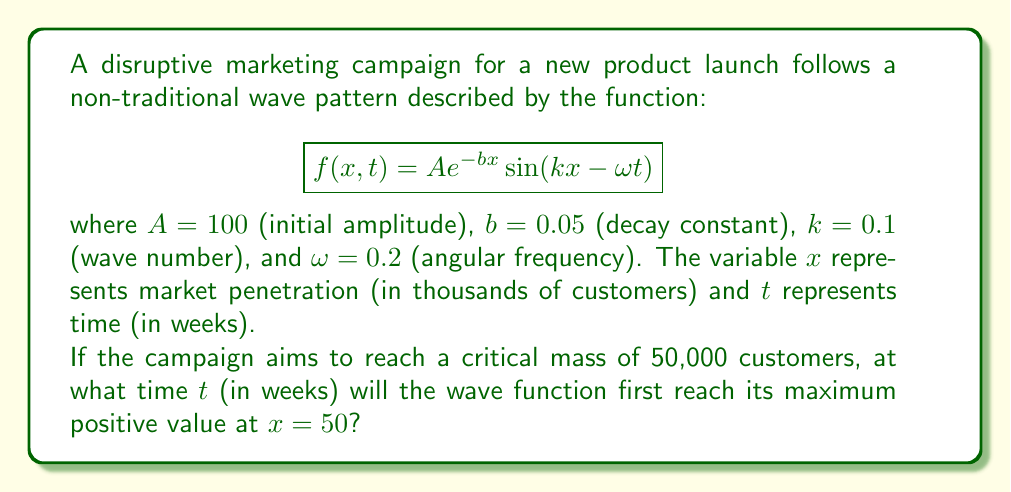Teach me how to tackle this problem. To solve this problem, we need to follow these steps:

1) The maximum positive value of a sine function occurs when the argument of sine is $\frac{\pi}{2} + 2\pi n$, where $n$ is any integer. In this case, we want:

   $$kx - \omega t = \frac{\pi}{2} + 2\pi n$$

2) We're interested in the first maximum, so we'll use $n = 0$. We're also given $x = 50$ (representing 50,000 customers). Substituting these and the given values:

   $$(0.1)(50) - (0.2)t = \frac{\pi}{2}$$

3) Simplify the left side:

   $$5 - 0.2t = \frac{\pi}{2}$$

4) Subtract 5 from both sides:

   $$-0.2t = \frac{\pi}{2} - 5$$

5) Multiply both sides by -5:

   $$t = 5\left(5 - \frac{\pi}{2}\right)$$

6) Calculate the final value:

   $$t = 25 - \frac{5\pi}{2} \approx 17.13$$

Therefore, the wave function will reach its first maximum positive value at $x = 50$ after approximately 17.13 weeks.
Answer: $25 - \frac{5\pi}{2}$ weeks 